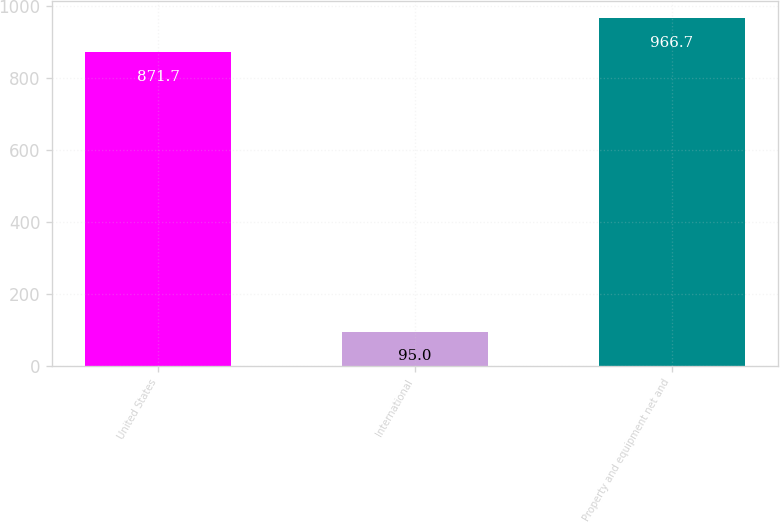Convert chart. <chart><loc_0><loc_0><loc_500><loc_500><bar_chart><fcel>United States<fcel>International<fcel>Property and equipment net and<nl><fcel>871.7<fcel>95<fcel>966.7<nl></chart> 